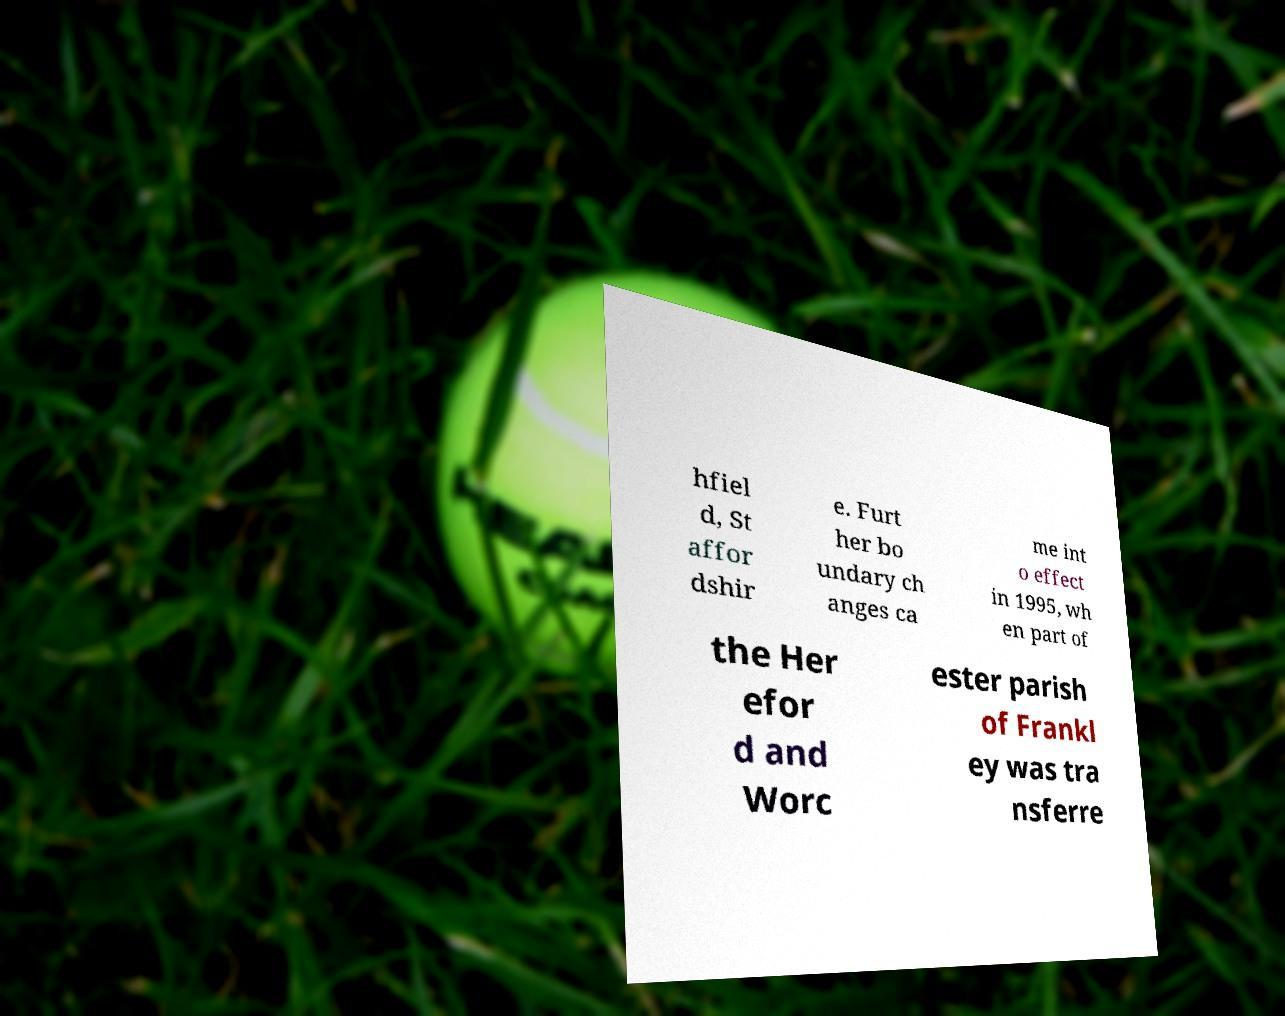Please read and relay the text visible in this image. What does it say? hfiel d, St affor dshir e. Furt her bo undary ch anges ca me int o effect in 1995, wh en part of the Her efor d and Worc ester parish of Frankl ey was tra nsferre 